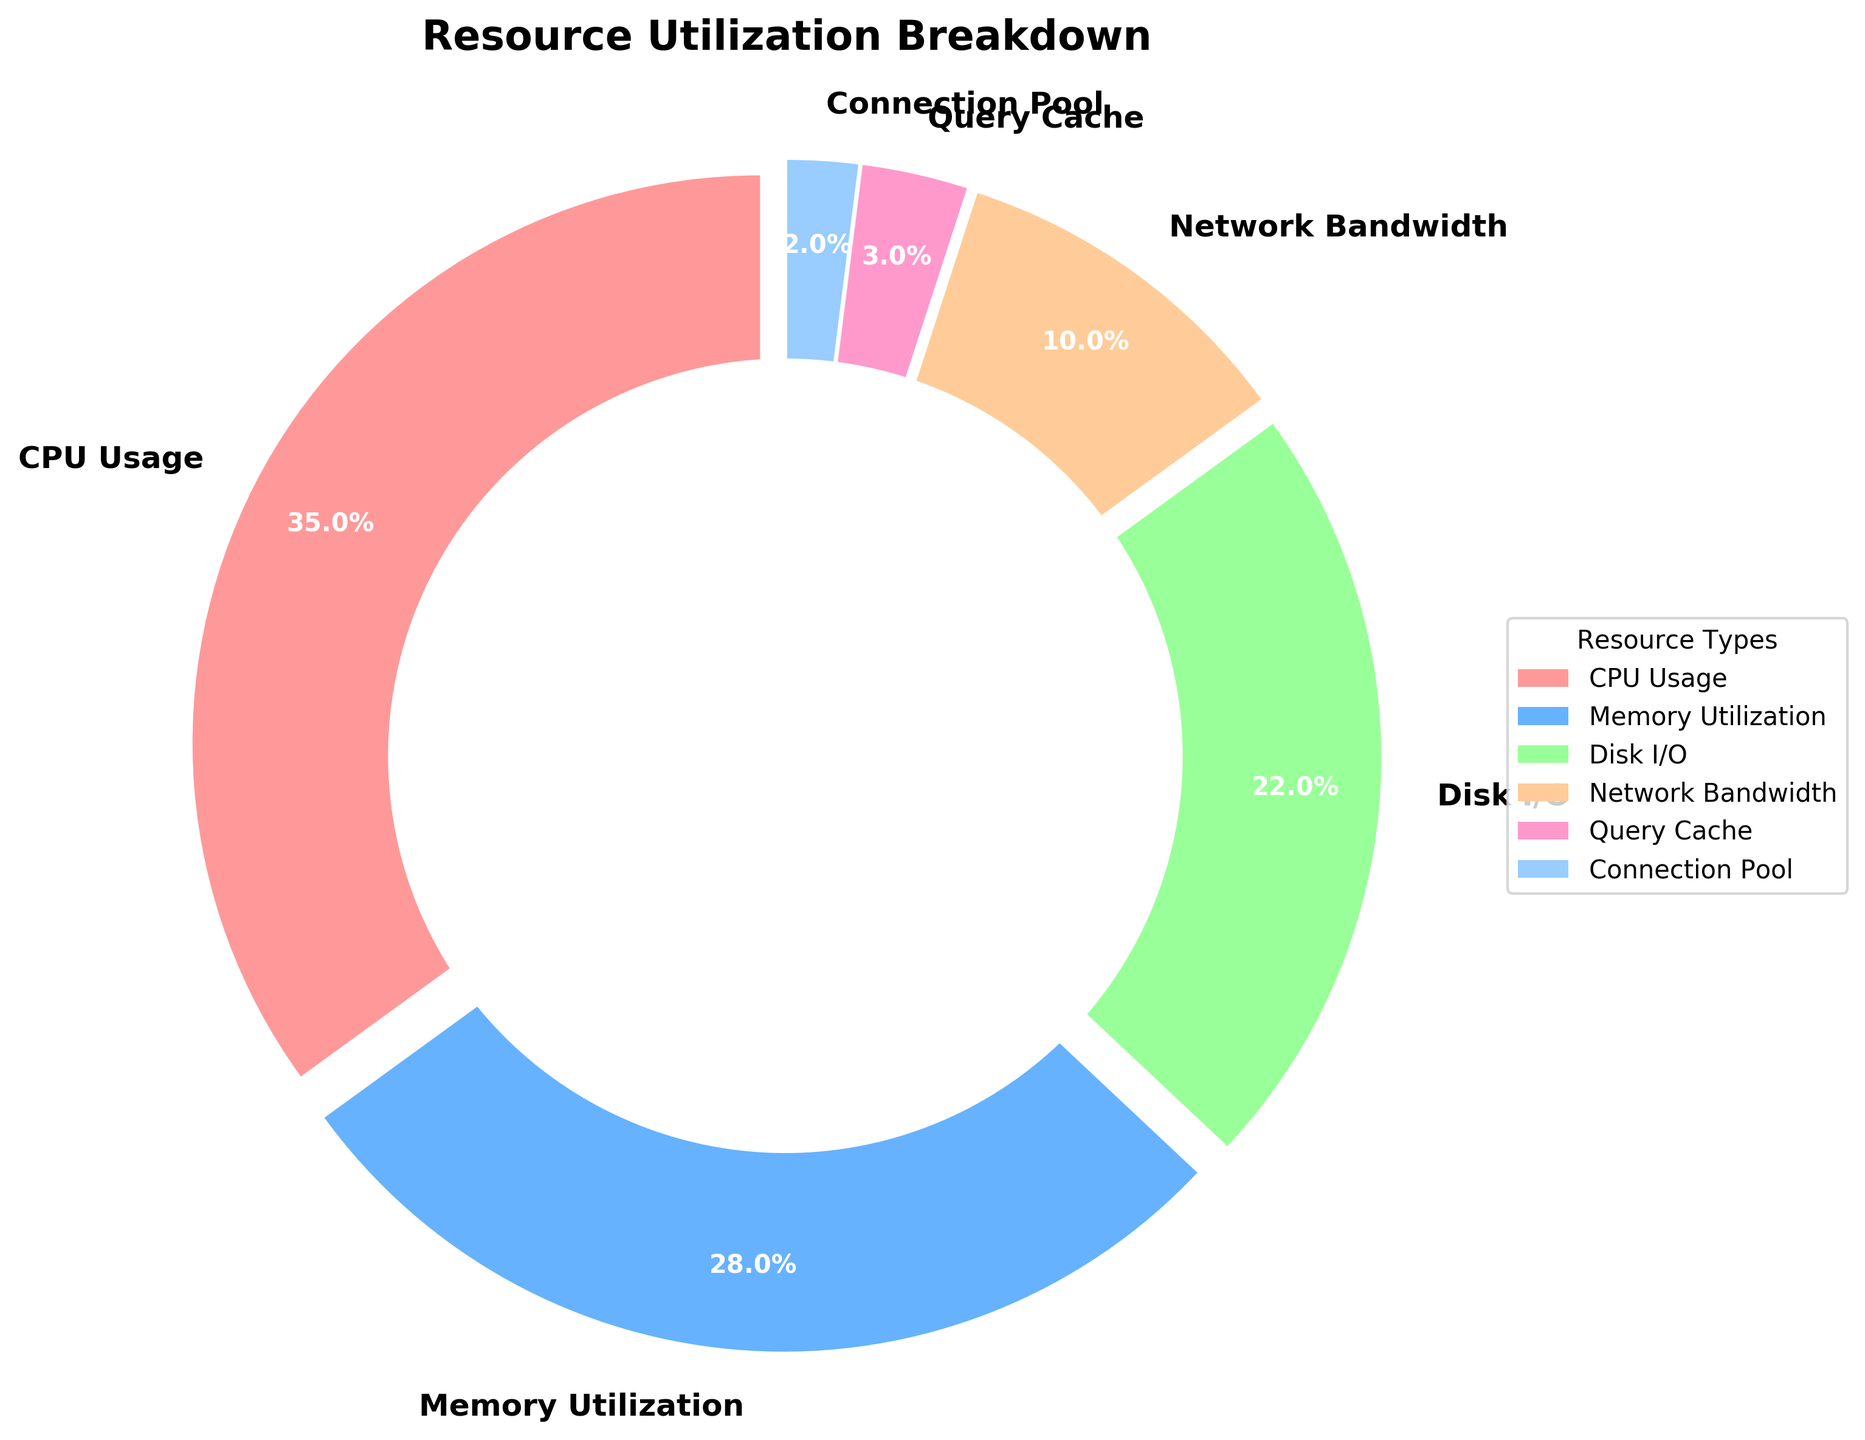What percentage of resource utilization is accounted for by CPU Usage and Memory Utilization together? To find the total percentage of resource utilization accounted for by CPU Usage and Memory Utilization, add their individual percentages: 35% (CPU Usage) + 28% (Memory Utilization) = 63%
Answer: 63% Which resource type has the smallest percentage utilization? To determine the resource type with the smallest percentage utilization, look at the labels and their corresponding percentages. Connection Pool has the smallest percentage of 2%
Answer: Connection Pool What is the difference in percentage between Disk I/O and Network Bandwidth? To find the difference in percentage between Disk I/O and Network Bandwidth, subtract the percentage of Network Bandwidth from Disk I/O: 22% (Disk I/O) - 10% (Network Bandwidth) = 12%
Answer: 12% Which resource type uses more resources: Query Cache or Connection Pool? To compare the resource usage between Query Cache and Connection Pool, look at their percentages. Query Cache is 3% and Connection Pool is 2%, so Query Cache uses more resources
Answer: Query Cache How much more percentage does CPU Usage have compared to Disk I/O? To find how much more percentage CPU Usage has compared to Disk I/O, subtract the percentage of Disk I/O from CPU Usage: 35% (CPU Usage) - 22% (Disk I/O) = 13%
Answer: 13% What percentage of resources is used by non-memory-related components (everything except Memory Utilization)? To find the percentage of resources used by non-memory-related components, add the percentages of all other components except Memory Utilization: 35% (CPU Usage) + 22% (Disk I/O) + 10% (Network Bandwidth) + 3% (Query Cache) + 2% (Connection Pool) = 72%
Answer: 72% Identify the resource type represented by the green section in the pie chart. To determine the resource type represented by the green section, note the color-keyed sections in the pie chart. The green section corresponds to Disk I/O
Answer: Disk I/O Which two resource types together account for the majority of resource utilization? To determine the resource types that together account for the majority (over 50%) of resource utilization, sum the highest individual percentages until the total exceeds 50%. CPU Usage (35%) and Memory Utilization (28%) together account for 63%, which is the majority
Answer: CPU Usage and Memory Utilization What is the combined utilization percentage of Network Bandwidth, Query Cache, and Connection Pool? To find the combined utilization percentage of Network Bandwidth, Query Cache, and Connection Pool, add their individual percentages: 10% (Network Bandwidth) + 3% (Query Cache) + 2% (Connection Pool) = 15%
Answer: 15% What percentage of resource utilization is more than the Network Bandwidth? To determine the resource utilization percentages that are more than Network Bandwidth (10%), look for any resource percentage greater than 10%. CPU Usage (35%), Memory Utilization (28%), and Disk I/O (22%) are all more than Network Bandwidth
Answer: CPU Usage, Memory Utilization, Disk I/O 